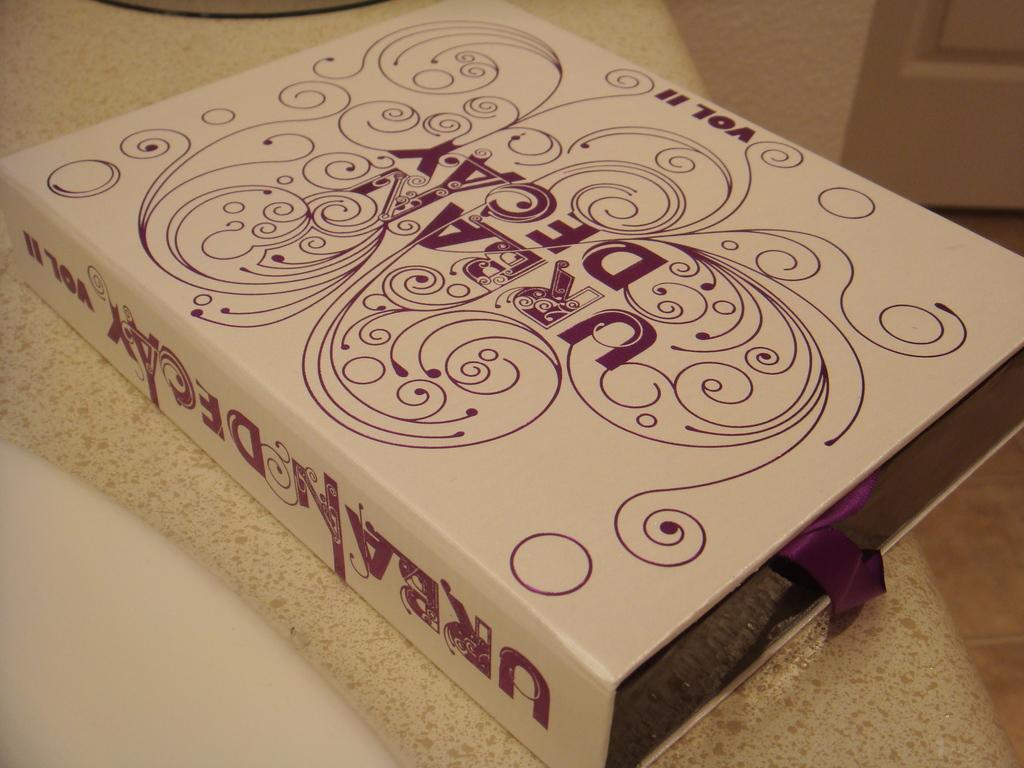What volume is this item?
Ensure brevity in your answer.  2. 